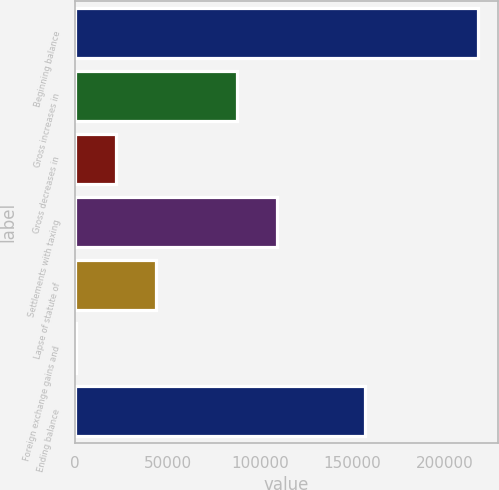Convert chart. <chart><loc_0><loc_0><loc_500><loc_500><bar_chart><fcel>Beginning balance<fcel>Gross increases in<fcel>Gross decreases in<fcel>Settlements with taxing<fcel>Lapse of statute of<fcel>Foreign exchange gains and<fcel>Ending balance<nl><fcel>218040<fcel>87407.4<fcel>22091.1<fcel>109180<fcel>43863.2<fcel>319<fcel>156925<nl></chart> 